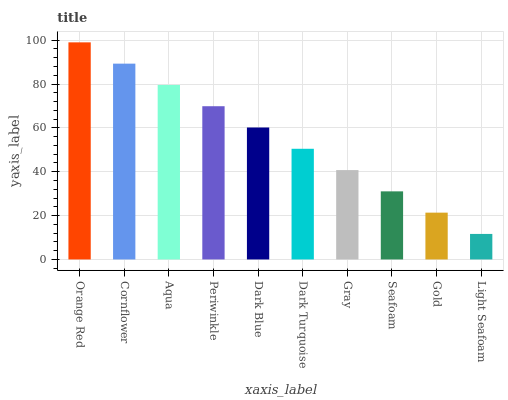Is Light Seafoam the minimum?
Answer yes or no. Yes. Is Orange Red the maximum?
Answer yes or no. Yes. Is Cornflower the minimum?
Answer yes or no. No. Is Cornflower the maximum?
Answer yes or no. No. Is Orange Red greater than Cornflower?
Answer yes or no. Yes. Is Cornflower less than Orange Red?
Answer yes or no. Yes. Is Cornflower greater than Orange Red?
Answer yes or no. No. Is Orange Red less than Cornflower?
Answer yes or no. No. Is Dark Blue the high median?
Answer yes or no. Yes. Is Dark Turquoise the low median?
Answer yes or no. Yes. Is Light Seafoam the high median?
Answer yes or no. No. Is Periwinkle the low median?
Answer yes or no. No. 